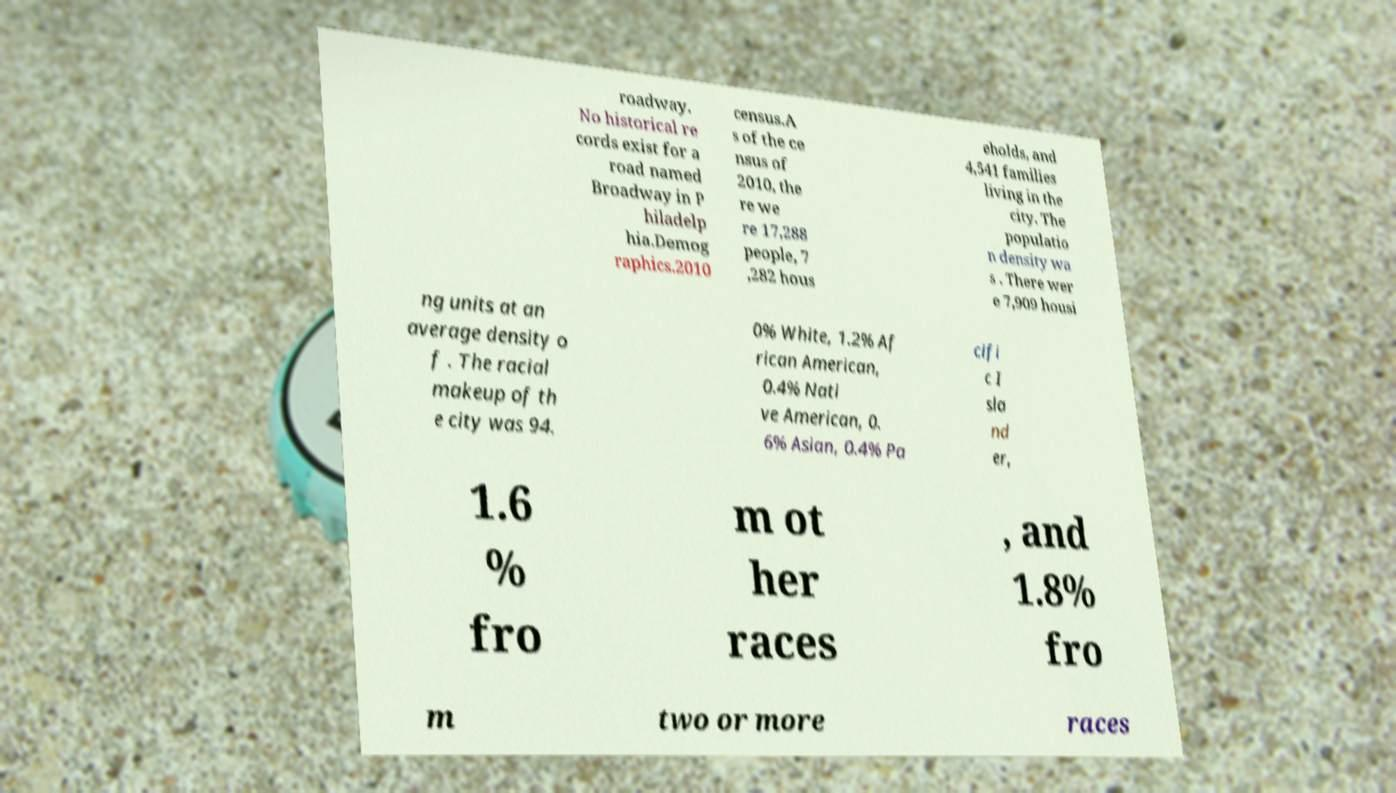Could you assist in decoding the text presented in this image and type it out clearly? roadway. No historical re cords exist for a road named Broadway in P hiladelp hia.Demog raphics.2010 census.A s of the ce nsus of 2010, the re we re 17,288 people, 7 ,282 hous eholds, and 4,541 families living in the city. The populatio n density wa s . There wer e 7,909 housi ng units at an average density o f . The racial makeup of th e city was 94. 0% White, 1.2% Af rican American, 0.4% Nati ve American, 0. 6% Asian, 0.4% Pa cifi c I sla nd er, 1.6 % fro m ot her races , and 1.8% fro m two or more races 